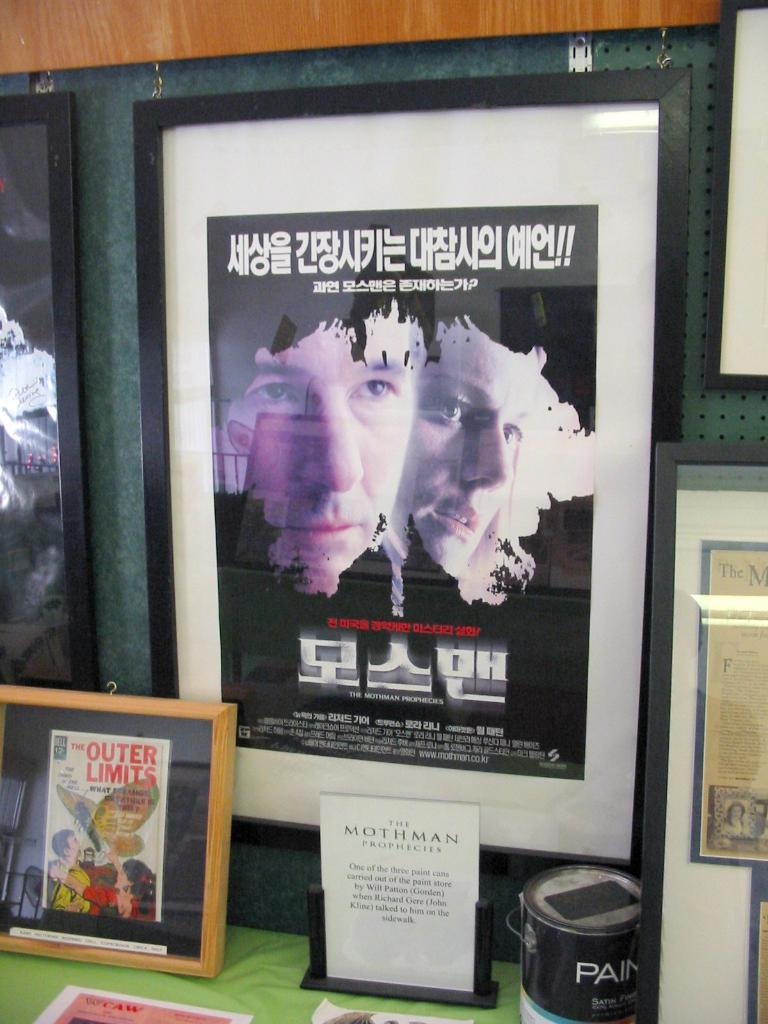<image>
Create a compact narrative representing the image presented. A framed Korean poster for the movie "The Mothman Prophecies" hangs on a wall with other displays. 